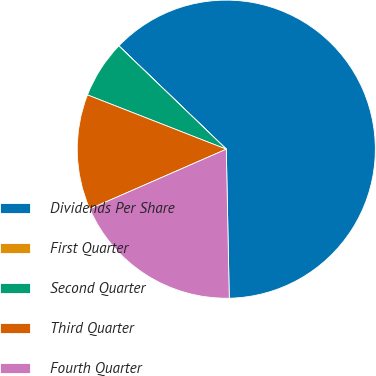Convert chart. <chart><loc_0><loc_0><loc_500><loc_500><pie_chart><fcel>Dividends Per Share<fcel>First Quarter<fcel>Second Quarter<fcel>Third Quarter<fcel>Fourth Quarter<nl><fcel>62.49%<fcel>0.01%<fcel>6.25%<fcel>12.5%<fcel>18.75%<nl></chart> 